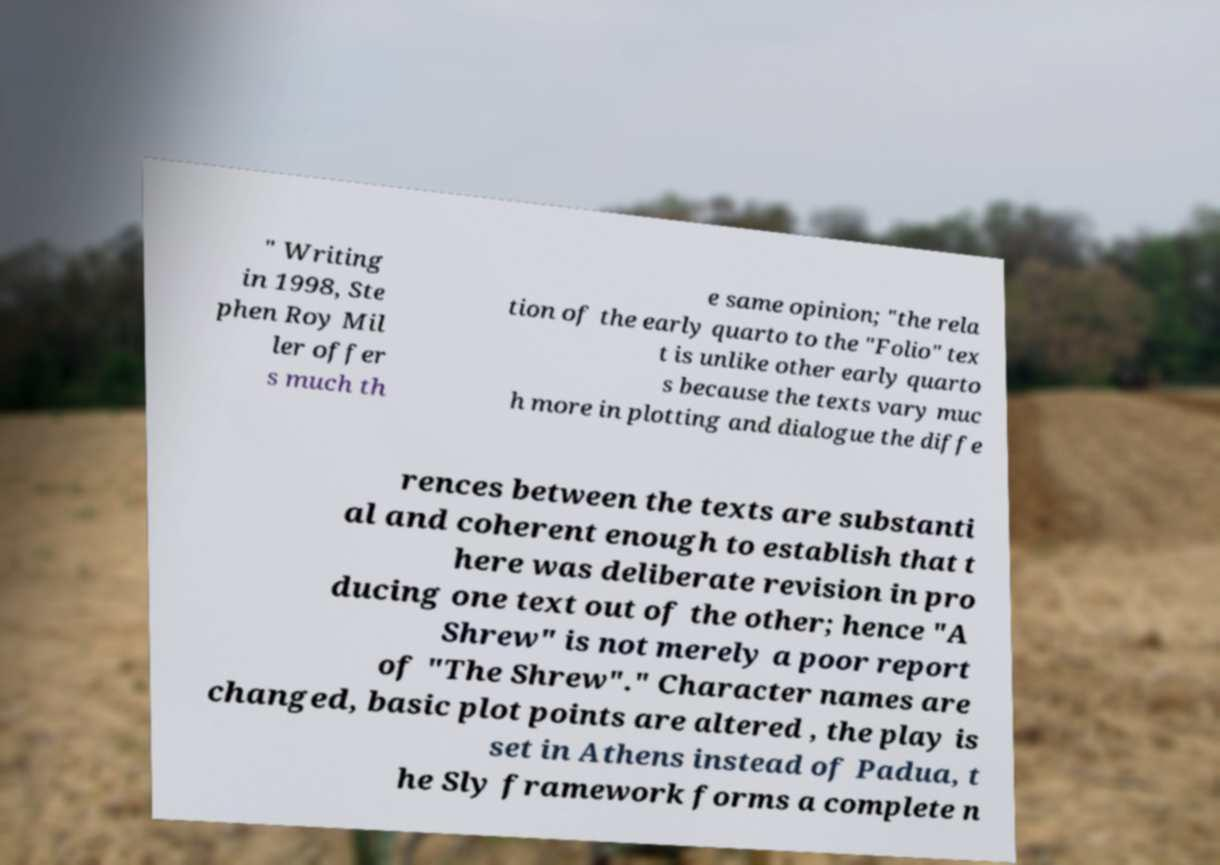Can you accurately transcribe the text from the provided image for me? " Writing in 1998, Ste phen Roy Mil ler offer s much th e same opinion; "the rela tion of the early quarto to the "Folio" tex t is unlike other early quarto s because the texts vary muc h more in plotting and dialogue the diffe rences between the texts are substanti al and coherent enough to establish that t here was deliberate revision in pro ducing one text out of the other; hence "A Shrew" is not merely a poor report of "The Shrew"." Character names are changed, basic plot points are altered , the play is set in Athens instead of Padua, t he Sly framework forms a complete n 